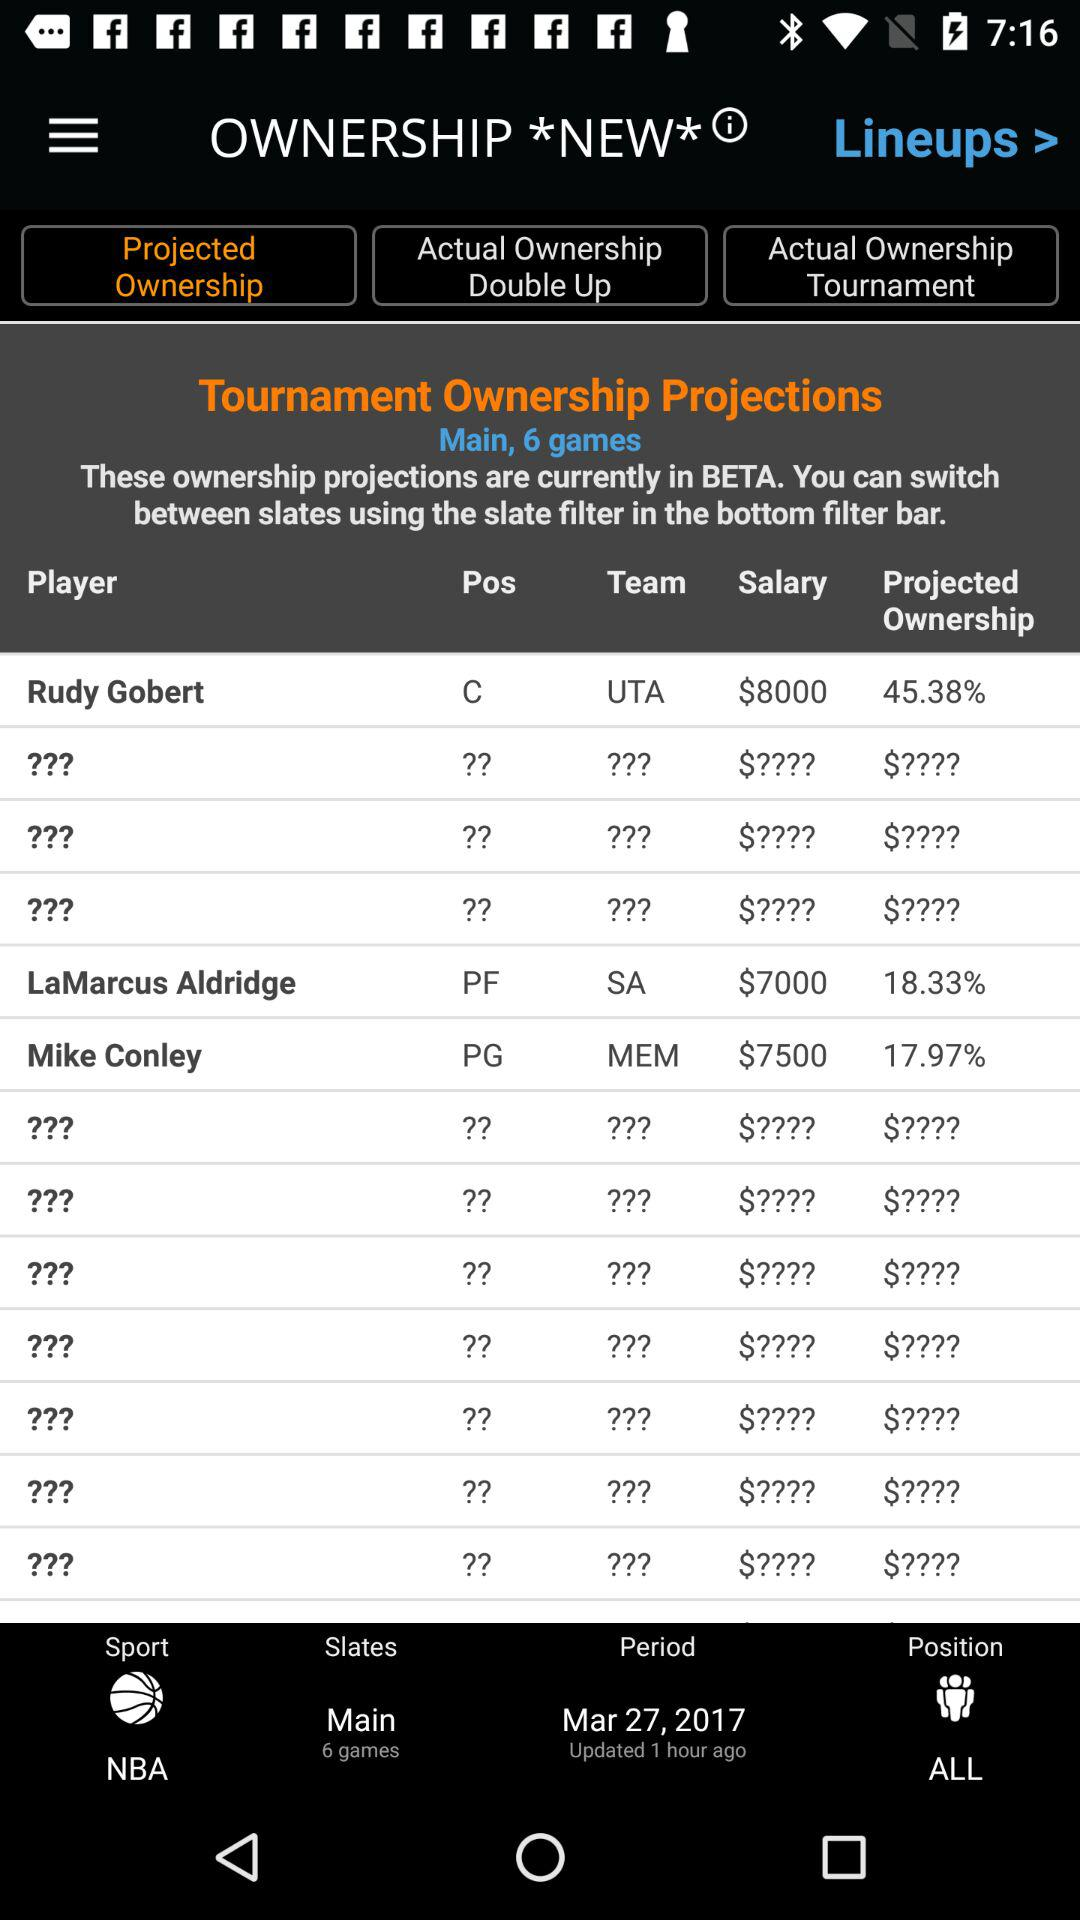What is the date of the period? The date is March 27, 2017. 